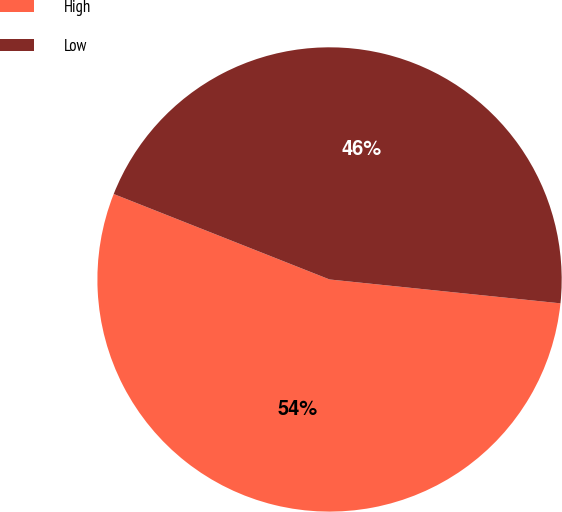Convert chart to OTSL. <chart><loc_0><loc_0><loc_500><loc_500><pie_chart><fcel>High<fcel>Low<nl><fcel>54.36%<fcel>45.64%<nl></chart> 